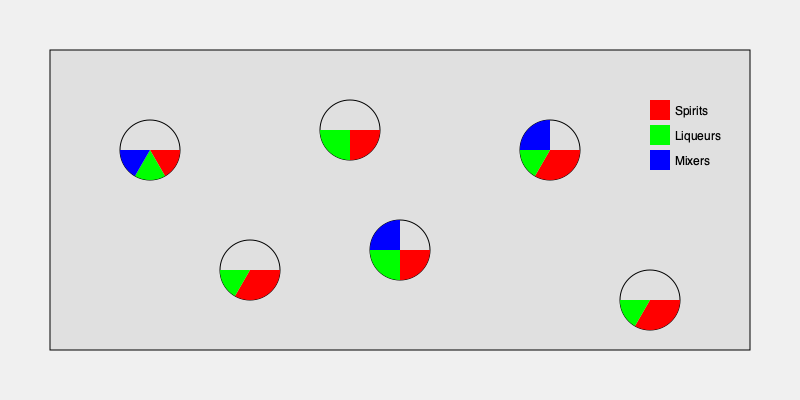Based on the world map visualization of signature cocktail ingredients, which continent shows the most balanced distribution of spirits, liqueurs, and mixers in their cocktails, and what implications might this have for a traveler seeking diverse drinking experiences? To answer this question, we need to analyze the pie charts for each continent:

1. North America: Roughly equal distribution of spirits (red), liqueurs (green), and mixers (blue).
2. Europe: Even split between spirits (red) and liqueurs (green), no significant mixer component.
3. Asia: Dominated by spirits (red), with smaller portions of liqueurs (green) and mixers (blue).
4. South America: Roughly equal split between spirits (red) and liqueurs (green), no significant mixer component.
5. Africa: Even distribution among spirits (red), liqueurs (green), and mixers (blue).
6. Australia: Roughly equal split between spirits (red) and liqueurs (green), no significant mixer component.

The most balanced distribution is observed in Africa and North America, as they both show a relatively even split among all three components: spirits, liqueurs, and mixers.

For a traveler seeking diverse drinking experiences, this implies:

1. Africa and North America might offer the most varied cocktail experiences, with a balance of different ingredient types.
2. Europe, South America, and Australia tend to focus more on spirit and liqueur combinations, potentially resulting in stronger, more alcohol-forward cocktails.
3. Asia appears to have a strong emphasis on spirit-based cocktails, which might result in more potent drinks or a focus on showcasing specific spirits.

A wanderlust-filled traveler would likely find the most diverse range of cocktail styles and flavors in Africa and North America, based on this ingredient distribution. However, each region's unique approach to cocktails could offer interesting experiences for the curious drinker.
Answer: Africa, offering the most balanced ingredient distribution and potentially diverse drinking experiences. 